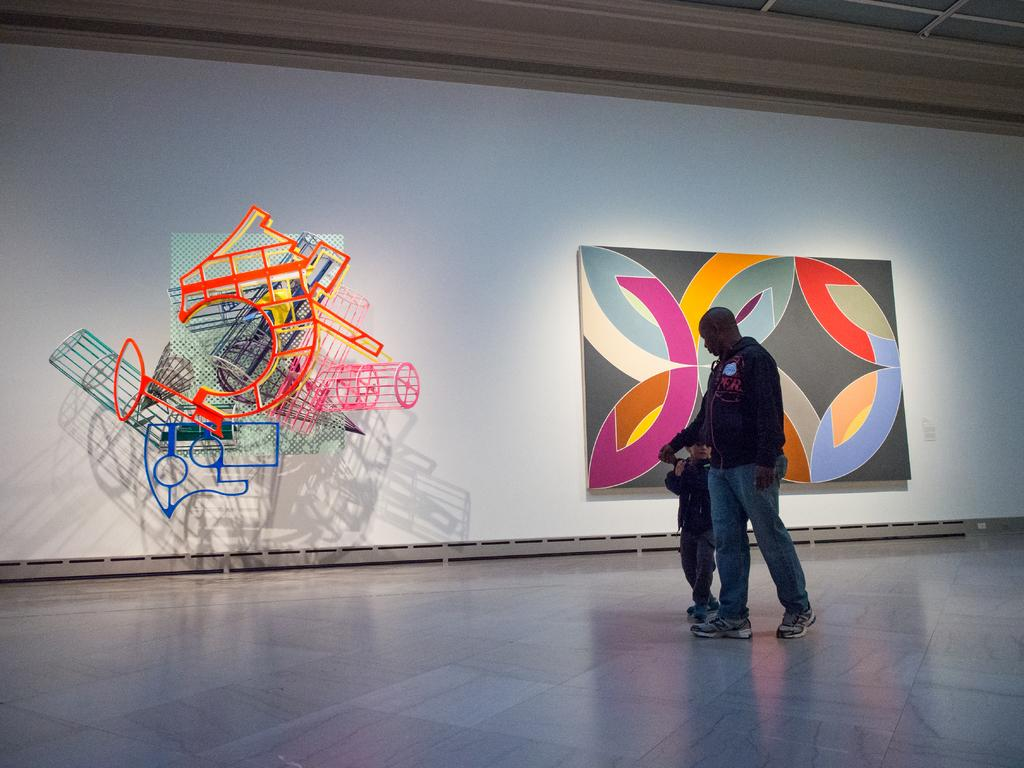What is happening on the stage in the image? There is a person and a child on the stage in the image. What is present on the screen on the stage? There is a screen on the stage in the image, and a board is attached to it. What can be seen on the board attached to the screen? There are objects attached to the board in the image. What part of the room can be seen above the stage? The ceiling is visible in the image. How many kittens are sleeping on the beds in the image? There are no kittens or beds present in the image. What type of crib is visible in the image? There is no crib present in the image. 